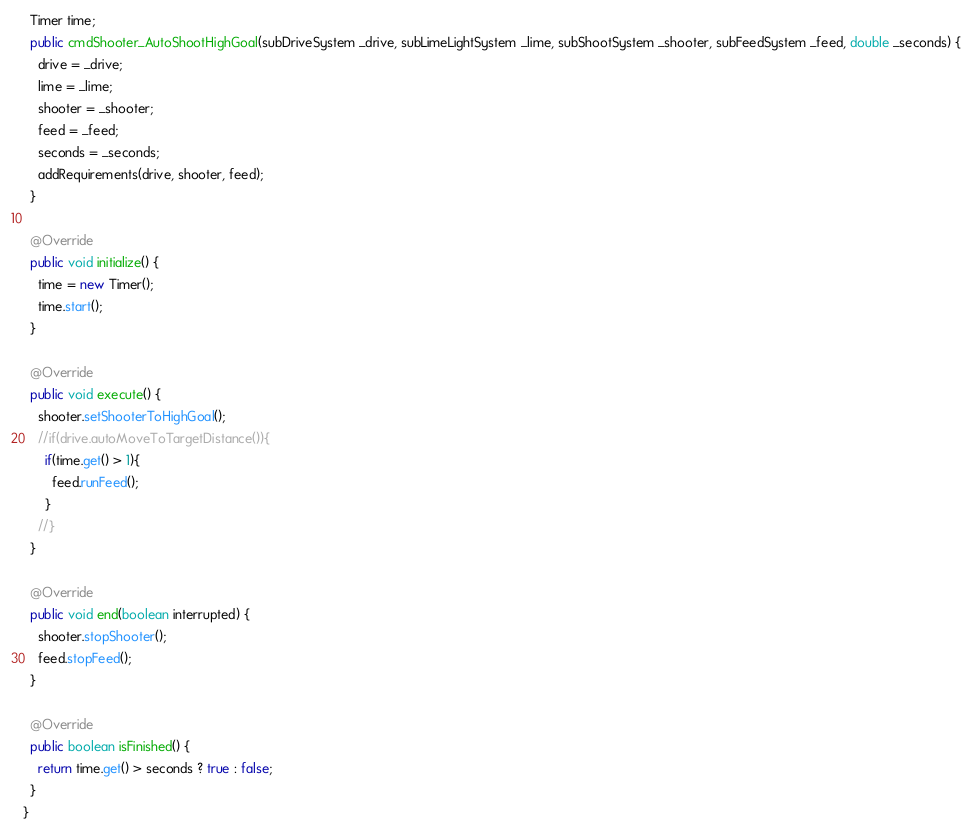Convert code to text. <code><loc_0><loc_0><loc_500><loc_500><_Java_>  Timer time;
  public cmdShooter_AutoShootHighGoal(subDriveSystem _drive, subLimeLightSystem _lime, subShootSystem _shooter, subFeedSystem _feed, double _seconds) {
    drive = _drive;
    lime = _lime;
    shooter = _shooter;
    feed = _feed;
    seconds = _seconds;
    addRequirements(drive, shooter, feed);
  }

  @Override
  public void initialize() {
    time = new Timer();
    time.start();
  }

  @Override
  public void execute() {
    shooter.setShooterToHighGoal();
    //if(drive.autoMoveToTargetDistance()){
      if(time.get() > 1){
        feed.runFeed();
      }
    //}
  }

  @Override
  public void end(boolean interrupted) {
    shooter.stopShooter();
    feed.stopFeed();
  }

  @Override
  public boolean isFinished() {
    return time.get() > seconds ? true : false;
  }
}
</code> 